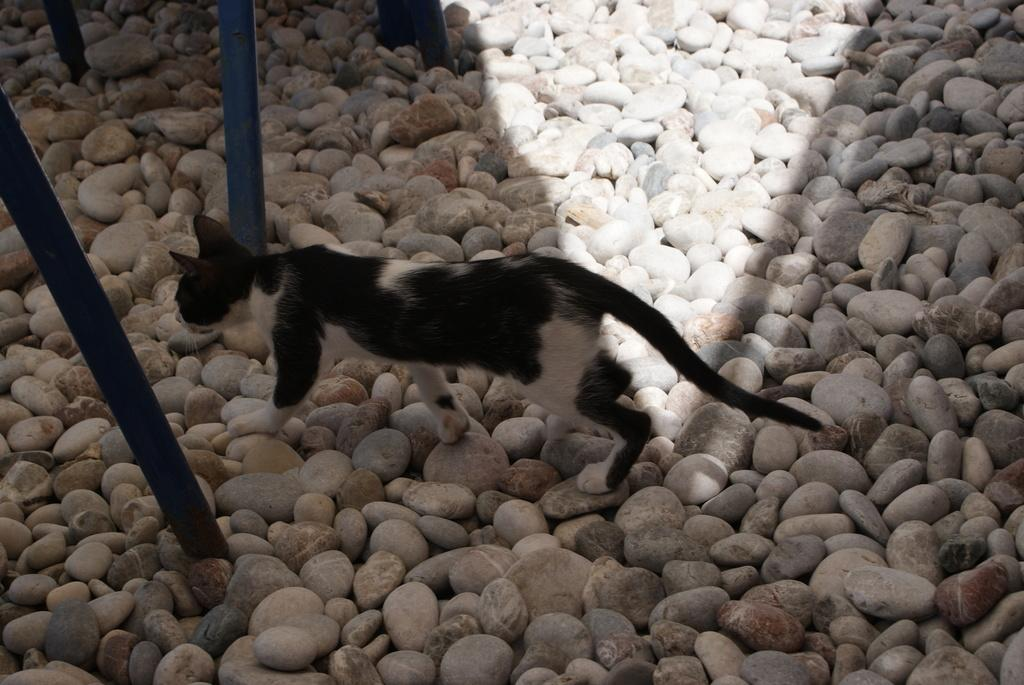What type of animal is in the image? There is a cat in the image. What is the cat standing on? The cat is standing on small rocks. Can you describe the cat's color pattern? The cat has a white and black color pattern. What else can be seen in the image besides the cat? There are rods visible in the image. How many toothbrushes are being used by the cat in the image? There are no toothbrushes present in the image, and the cat is not using any. 